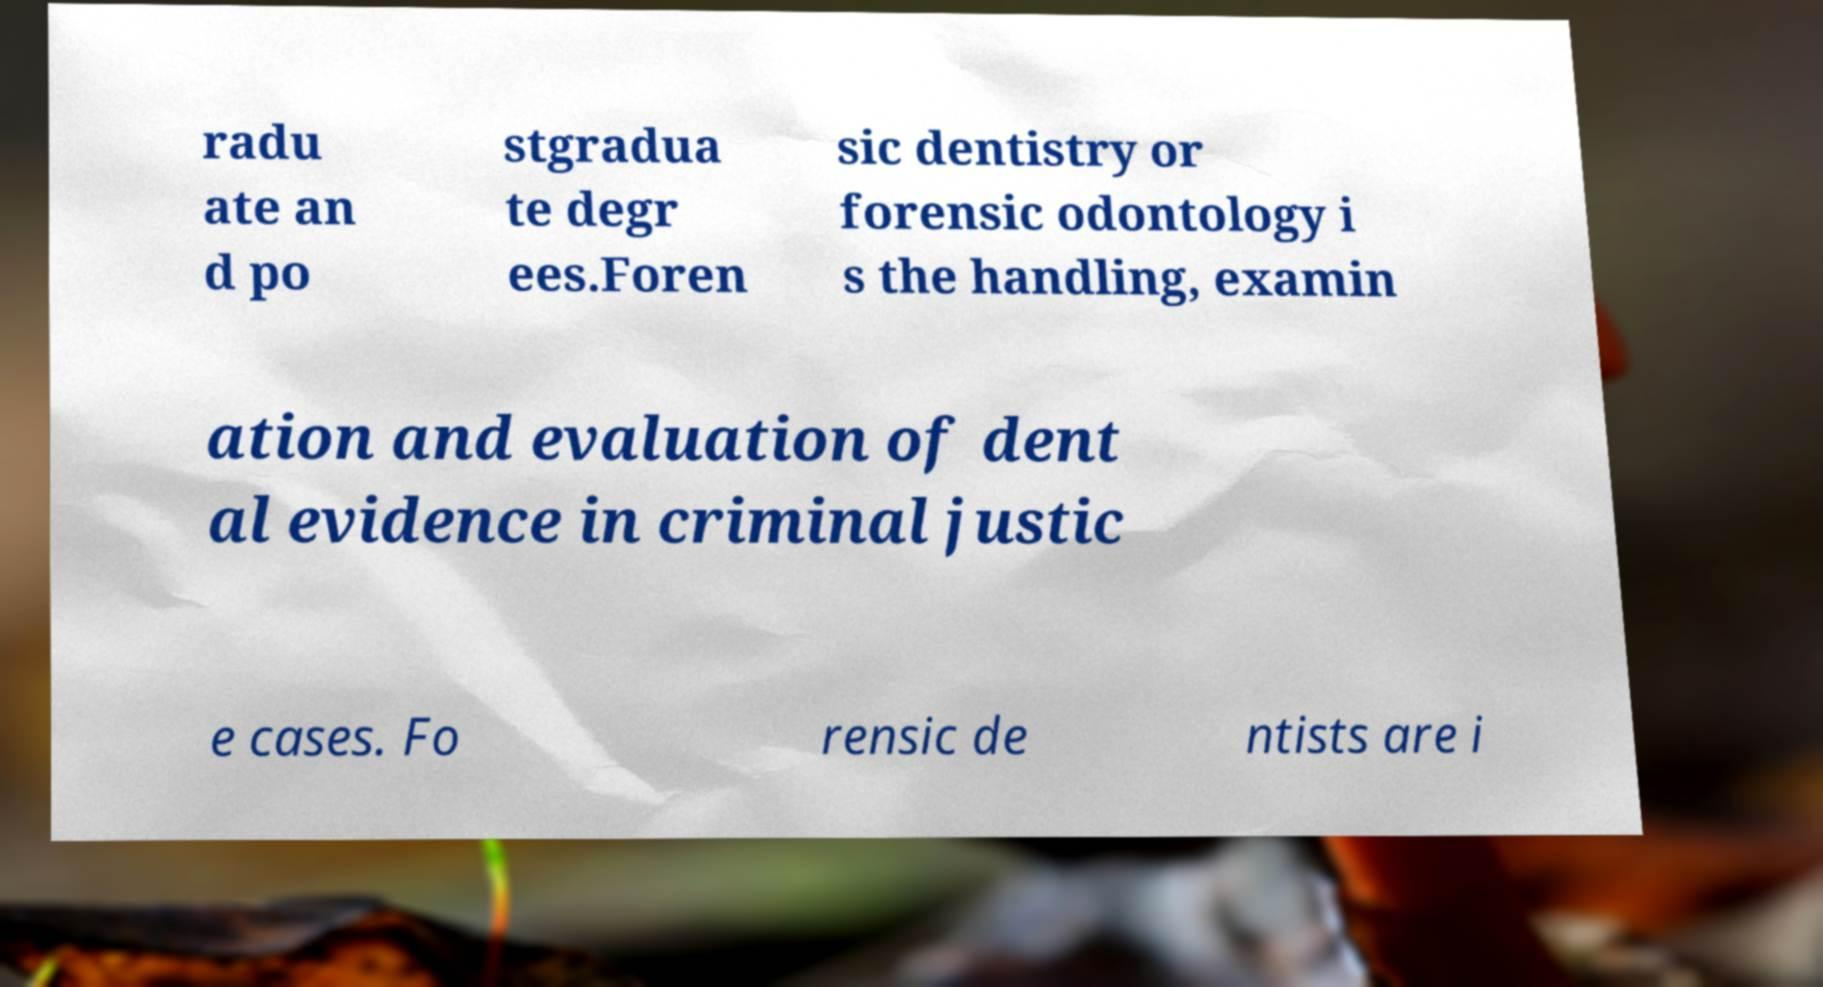Please identify and transcribe the text found in this image. radu ate an d po stgradua te degr ees.Foren sic dentistry or forensic odontology i s the handling, examin ation and evaluation of dent al evidence in criminal justic e cases. Fo rensic de ntists are i 